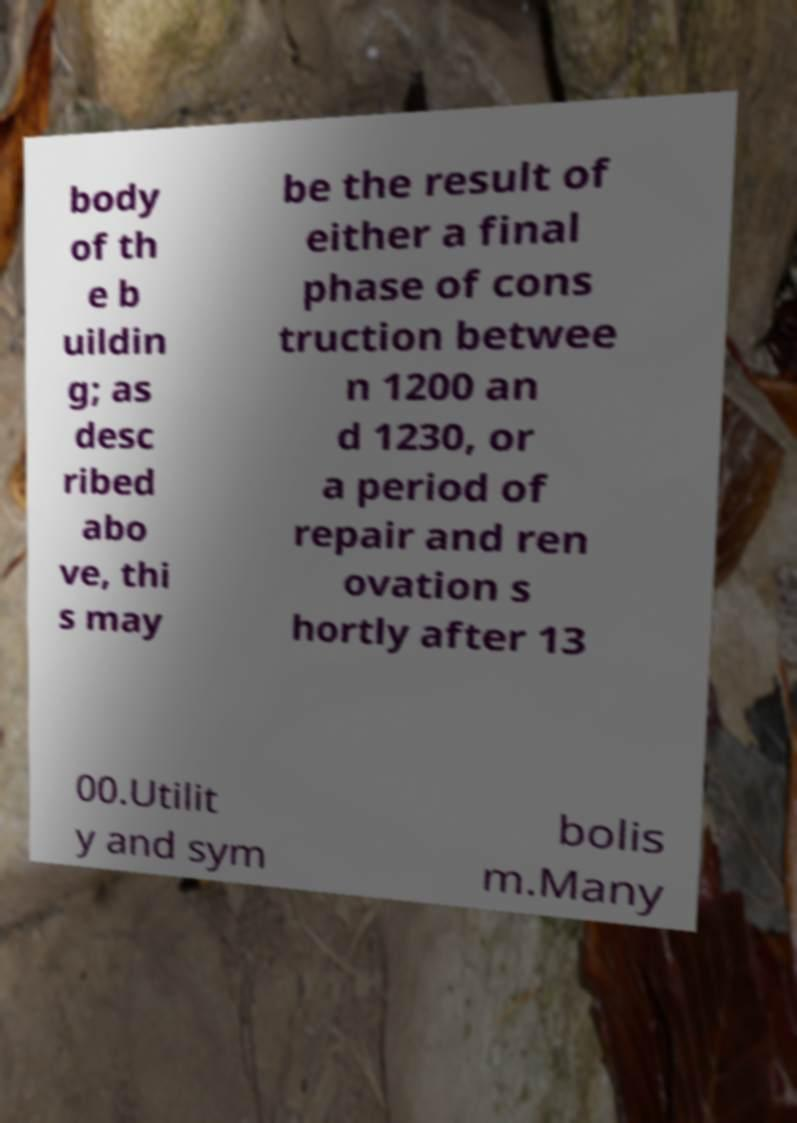Can you accurately transcribe the text from the provided image for me? body of th e b uildin g; as desc ribed abo ve, thi s may be the result of either a final phase of cons truction betwee n 1200 an d 1230, or a period of repair and ren ovation s hortly after 13 00.Utilit y and sym bolis m.Many 